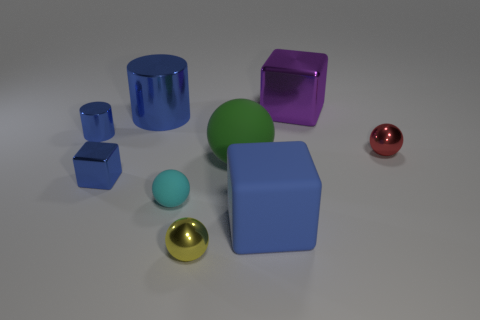What size is the rubber cube that is the same color as the small metal block? The rubber cube shares its color with the small, blue metal block on the left. Its size can be described as medium when compared to the other objects in the image. 